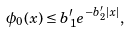<formula> <loc_0><loc_0><loc_500><loc_500>\phi _ { 0 } ( x ) \leq b ^ { \prime } _ { 1 } e ^ { - b ^ { \prime } _ { 2 } | x | } ,</formula> 